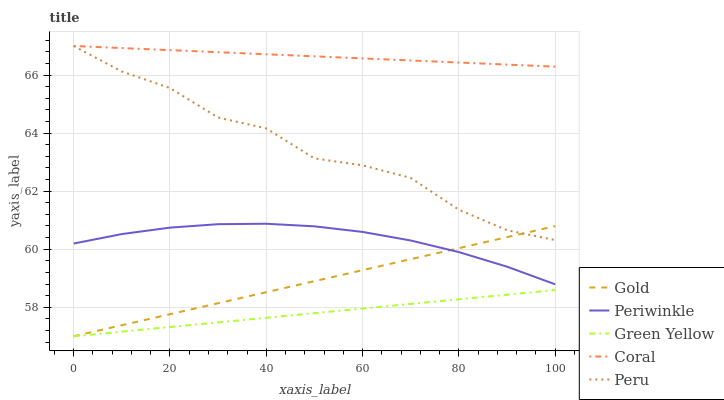Does Green Yellow have the minimum area under the curve?
Answer yes or no. Yes. Does Coral have the maximum area under the curve?
Answer yes or no. Yes. Does Periwinkle have the minimum area under the curve?
Answer yes or no. No. Does Periwinkle have the maximum area under the curve?
Answer yes or no. No. Is Gold the smoothest?
Answer yes or no. Yes. Is Peru the roughest?
Answer yes or no. Yes. Is Green Yellow the smoothest?
Answer yes or no. No. Is Green Yellow the roughest?
Answer yes or no. No. Does Green Yellow have the lowest value?
Answer yes or no. Yes. Does Periwinkle have the lowest value?
Answer yes or no. No. Does Peru have the highest value?
Answer yes or no. Yes. Does Periwinkle have the highest value?
Answer yes or no. No. Is Green Yellow less than Periwinkle?
Answer yes or no. Yes. Is Coral greater than Periwinkle?
Answer yes or no. Yes. Does Gold intersect Peru?
Answer yes or no. Yes. Is Gold less than Peru?
Answer yes or no. No. Is Gold greater than Peru?
Answer yes or no. No. Does Green Yellow intersect Periwinkle?
Answer yes or no. No. 